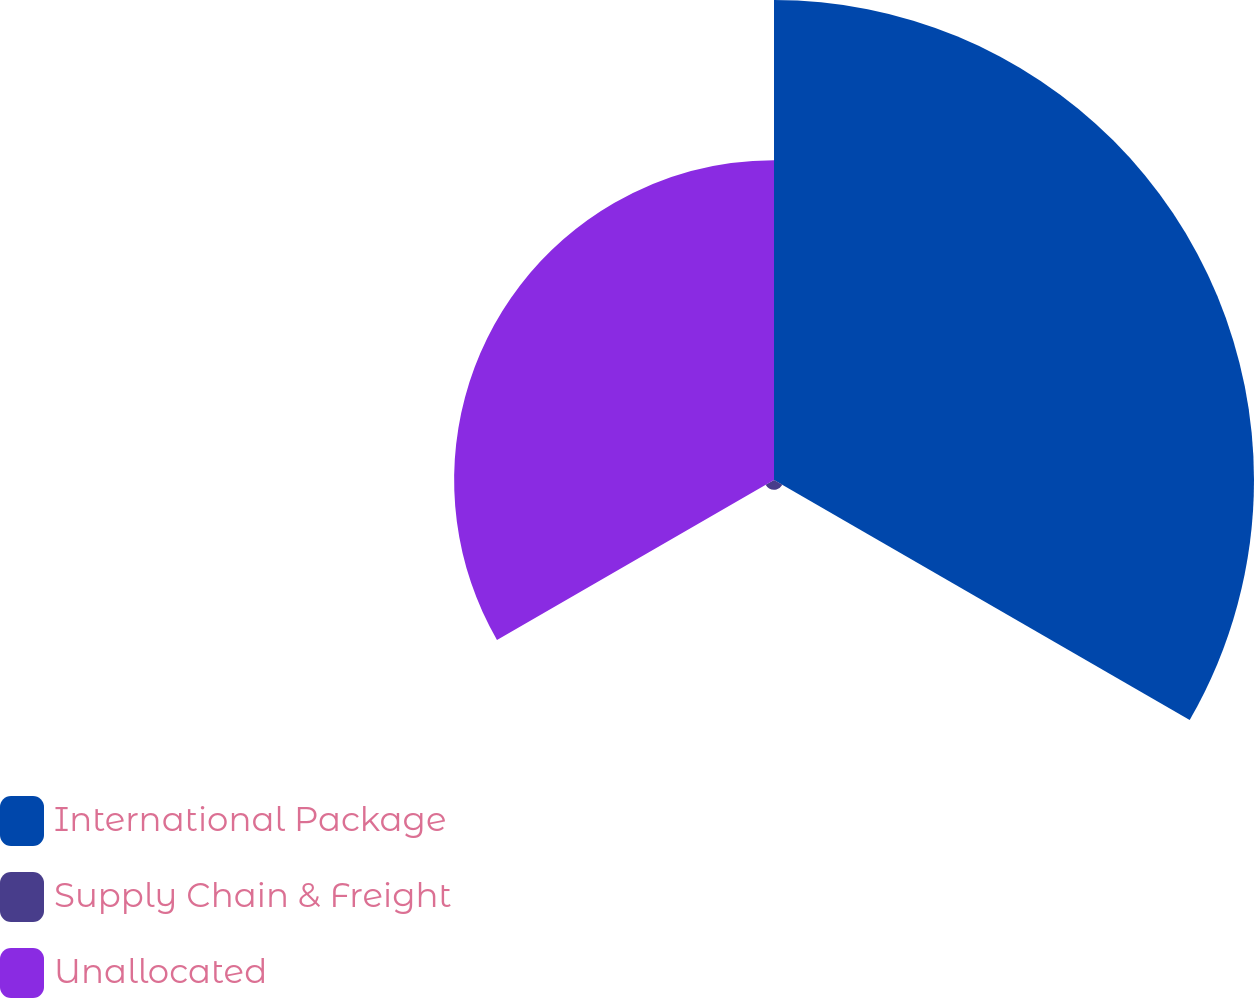Convert chart to OTSL. <chart><loc_0><loc_0><loc_500><loc_500><pie_chart><fcel>International Package<fcel>Supply Chain & Freight<fcel>Unallocated<nl><fcel>59.29%<fcel>1.2%<fcel>39.51%<nl></chart> 